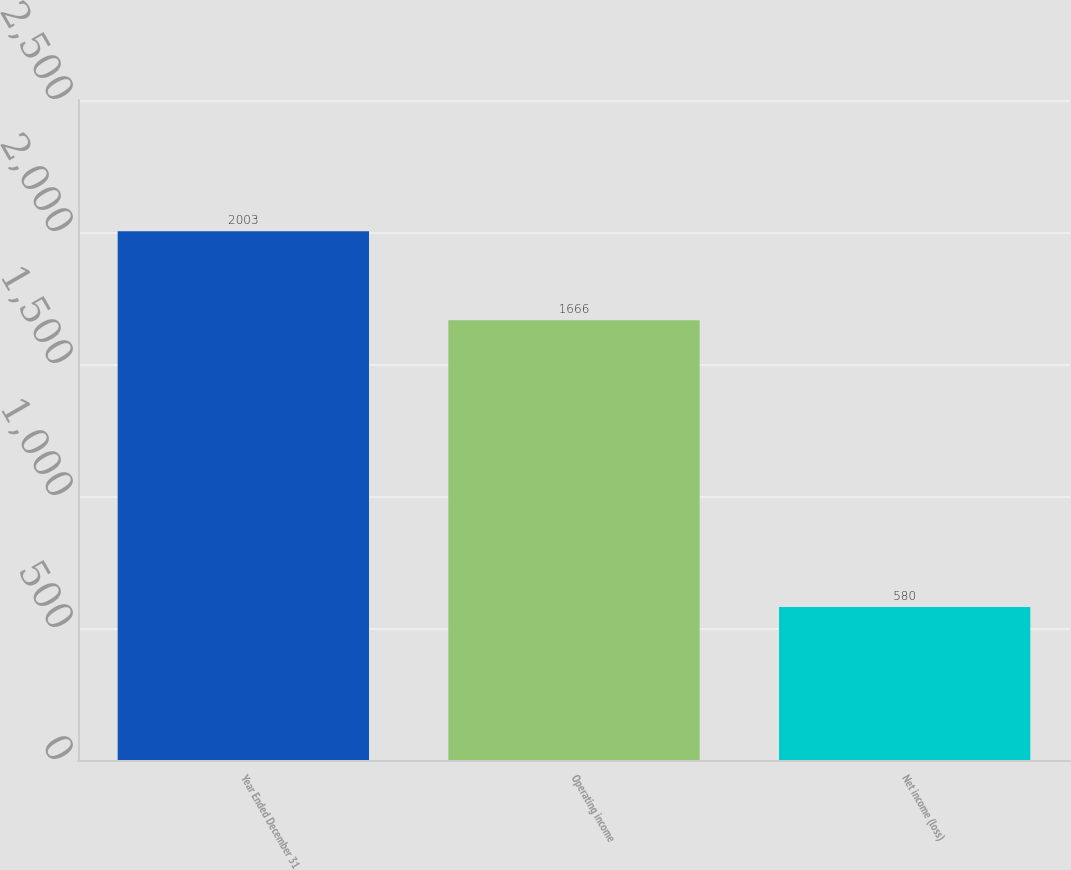<chart> <loc_0><loc_0><loc_500><loc_500><bar_chart><fcel>Year Ended December 31<fcel>Operating income<fcel>Net income (loss)<nl><fcel>2003<fcel>1666<fcel>580<nl></chart> 